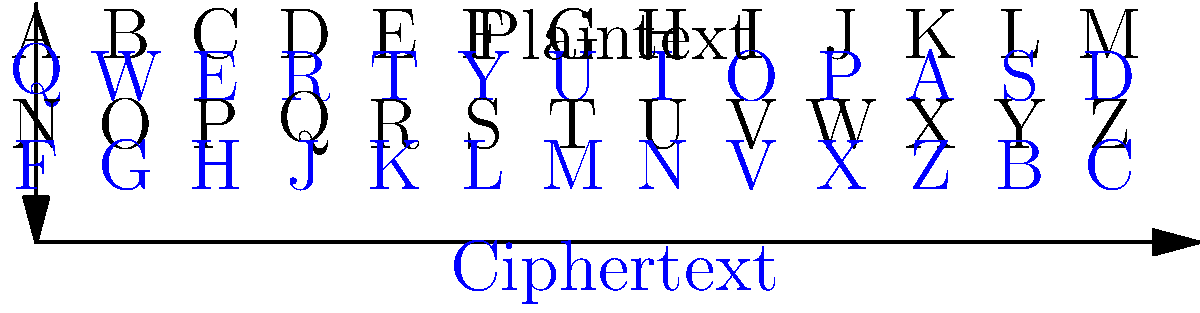Using the substitution cipher chart provided, decode the following encrypted message: "MIOL OL Q LTEKTM DTLLQUT". What investigative technique does this decryption method simulate? To decode the encrypted message, we'll use the substitution cipher chart to replace each letter in the ciphertext with its corresponding plaintext letter. Let's go through this step-by-step:

1. M -> T
2. I -> H
3. O -> I
4. L -> S
5. O -> I
6. L -> S
7. Q -> A
8. L -> S
9. T -> E
10. E -> C
11. K -> R
12. T -> E
13. M -> T

After substitution, we get: "THIS IS A SECRET MESSAGE"

This decryption method simulates the investigative technique of cryptanalysis, specifically the process of breaking a simple substitution cipher. In real investigations, this technique is often used to decipher coded messages or documents that may contain valuable information related to a case.

Cryptanalysis is an essential skill for private investigators when dealing with cases involving encrypted communications. It requires patience, pattern recognition, and analytical thinking - all key traits of a successful investigator.
Answer: Cryptanalysis 